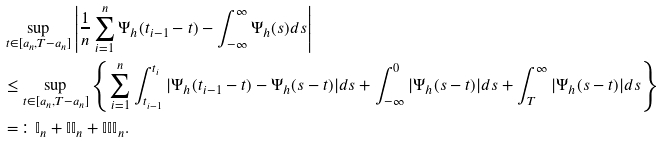Convert formula to latex. <formula><loc_0><loc_0><loc_500><loc_500>& \sup _ { t \in [ a _ { n } , T - a _ { n } ] } \left | \frac { 1 } { n } \sum _ { i = 1 } ^ { n } \Psi _ { h } ( t _ { i - 1 } - t ) - \int _ { - \infty } ^ { \infty } \Psi _ { h } ( s ) d s \right | \\ & \leq \sup _ { t \in [ a _ { n } , T - a _ { n } ] } \left \{ \sum _ { i = 1 } ^ { n } \int _ { t _ { i - 1 } } ^ { t _ { i } } | \Psi _ { h } ( t _ { i - 1 } - t ) - \Psi _ { h } ( s - t ) | d s + \int _ { - \infty } ^ { 0 } | \Psi _ { h } ( s - t ) | d s + \int _ { T } ^ { \infty } | \Psi _ { h } ( s - t ) | d s \right \} \\ & = \colon \mathbb { I } _ { n } + \mathbb { I I } _ { n } + \mathbb { I I I } _ { n } .</formula> 